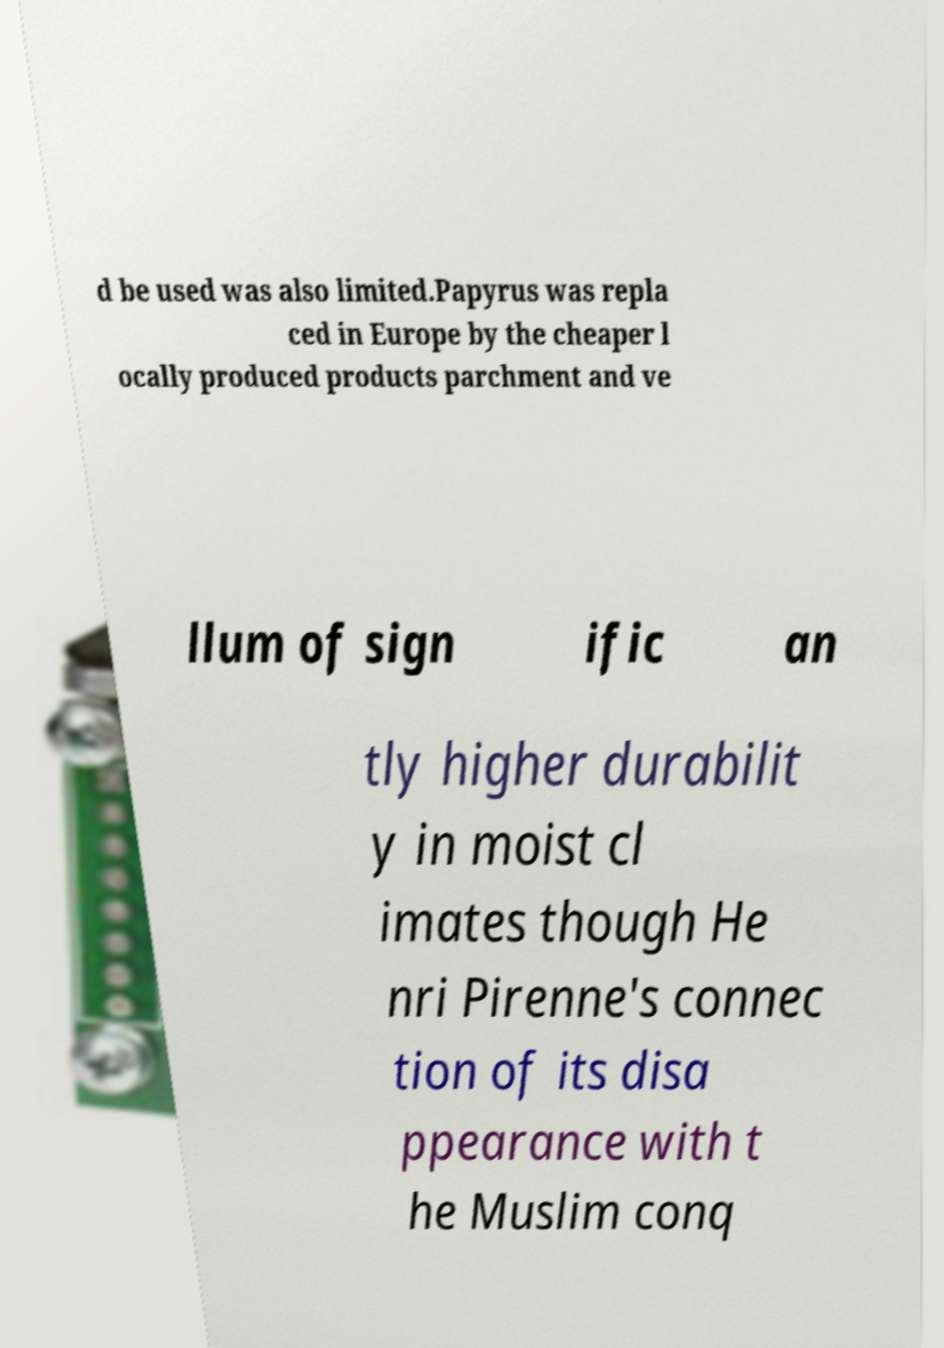Could you extract and type out the text from this image? d be used was also limited.Papyrus was repla ced in Europe by the cheaper l ocally produced products parchment and ve llum of sign ific an tly higher durabilit y in moist cl imates though He nri Pirenne's connec tion of its disa ppearance with t he Muslim conq 